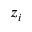Convert formula to latex. <formula><loc_0><loc_0><loc_500><loc_500>z _ { i }</formula> 